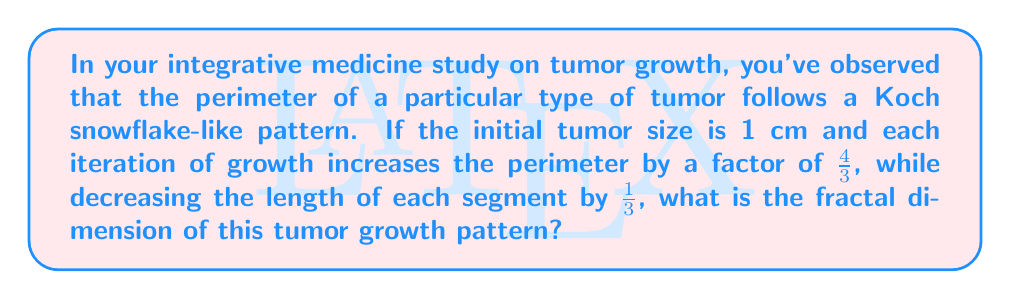Help me with this question. To calculate the fractal dimension of this tumor growth pattern, we'll use the box-counting method, which is defined by the formula:

$$D = \frac{\log N}{\log (1/r)}$$

Where:
$D$ is the fractal dimension
$N$ is the number of self-similar pieces
$r$ is the scaling factor

For this tumor growth pattern:

1. In each iteration, the number of segments increases by a factor of 4:
   $N = 4$

2. The scaling factor is the ratio by which each segment is reduced:
   $r = 1/3$

3. Plugging these values into the formula:

   $$D = \frac{\log 4}{\log (1/(1/3))} = \frac{\log 4}{\log 3}$$

4. Calculating the result:

   $$D = \frac{\log 4}{\log 3} \approx 1.2618595071429148$$

This fractal dimension between 1 and 2 indicates that the tumor growth pattern is more complex than a simple line (dimension 1) but doesn't fully fill a 2-dimensional space.
Answer: $\frac{\log 4}{\log 3} \approx 1.2619$ 